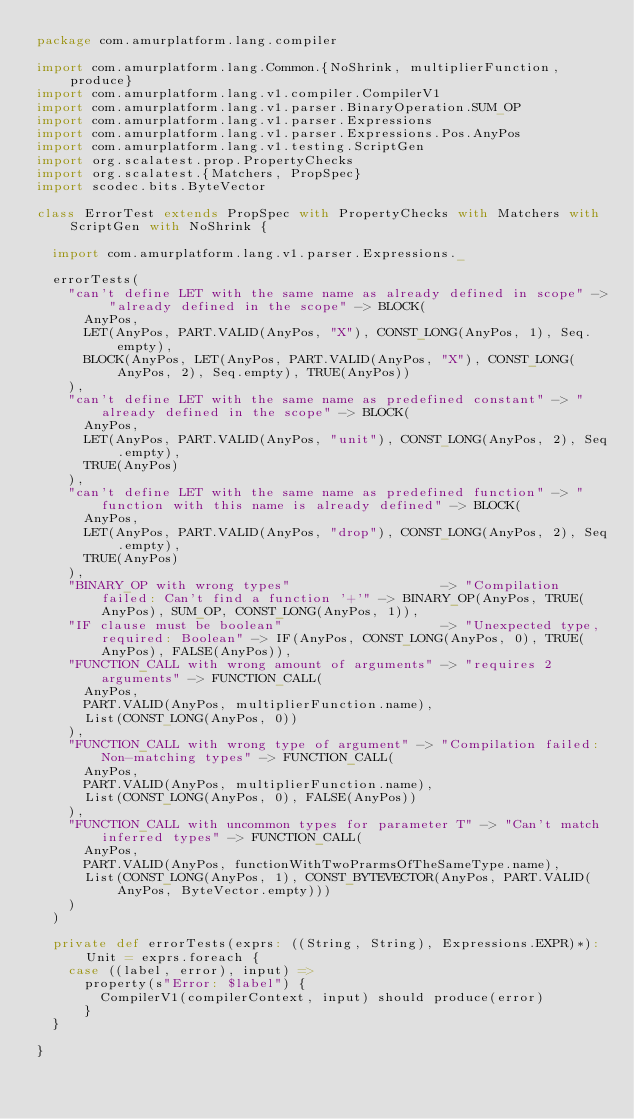Convert code to text. <code><loc_0><loc_0><loc_500><loc_500><_Scala_>package com.amurplatform.lang.compiler

import com.amurplatform.lang.Common.{NoShrink, multiplierFunction, produce}
import com.amurplatform.lang.v1.compiler.CompilerV1
import com.amurplatform.lang.v1.parser.BinaryOperation.SUM_OP
import com.amurplatform.lang.v1.parser.Expressions
import com.amurplatform.lang.v1.parser.Expressions.Pos.AnyPos
import com.amurplatform.lang.v1.testing.ScriptGen
import org.scalatest.prop.PropertyChecks
import org.scalatest.{Matchers, PropSpec}
import scodec.bits.ByteVector

class ErrorTest extends PropSpec with PropertyChecks with Matchers with ScriptGen with NoShrink {

  import com.amurplatform.lang.v1.parser.Expressions._

  errorTests(
    "can't define LET with the same name as already defined in scope" -> "already defined in the scope" -> BLOCK(
      AnyPos,
      LET(AnyPos, PART.VALID(AnyPos, "X"), CONST_LONG(AnyPos, 1), Seq.empty),
      BLOCK(AnyPos, LET(AnyPos, PART.VALID(AnyPos, "X"), CONST_LONG(AnyPos, 2), Seq.empty), TRUE(AnyPos))
    ),
    "can't define LET with the same name as predefined constant" -> "already defined in the scope" -> BLOCK(
      AnyPos,
      LET(AnyPos, PART.VALID(AnyPos, "unit"), CONST_LONG(AnyPos, 2), Seq.empty),
      TRUE(AnyPos)
    ),
    "can't define LET with the same name as predefined function" -> "function with this name is already defined" -> BLOCK(
      AnyPos,
      LET(AnyPos, PART.VALID(AnyPos, "drop"), CONST_LONG(AnyPos, 2), Seq.empty),
      TRUE(AnyPos)
    ),
    "BINARY_OP with wrong types"                   -> "Compilation failed: Can't find a function '+'" -> BINARY_OP(AnyPos, TRUE(AnyPos), SUM_OP, CONST_LONG(AnyPos, 1)),
    "IF clause must be boolean"                    -> "Unexpected type, required: Boolean" -> IF(AnyPos, CONST_LONG(AnyPos, 0), TRUE(AnyPos), FALSE(AnyPos)),
    "FUNCTION_CALL with wrong amount of arguments" -> "requires 2 arguments" -> FUNCTION_CALL(
      AnyPos,
      PART.VALID(AnyPos, multiplierFunction.name),
      List(CONST_LONG(AnyPos, 0))
    ),
    "FUNCTION_CALL with wrong type of argument" -> "Compilation failed: Non-matching types" -> FUNCTION_CALL(
      AnyPos,
      PART.VALID(AnyPos, multiplierFunction.name),
      List(CONST_LONG(AnyPos, 0), FALSE(AnyPos))
    ),
    "FUNCTION_CALL with uncommon types for parameter T" -> "Can't match inferred types" -> FUNCTION_CALL(
      AnyPos,
      PART.VALID(AnyPos, functionWithTwoPrarmsOfTheSameType.name),
      List(CONST_LONG(AnyPos, 1), CONST_BYTEVECTOR(AnyPos, PART.VALID(AnyPos, ByteVector.empty)))
    )
  )

  private def errorTests(exprs: ((String, String), Expressions.EXPR)*): Unit = exprs.foreach {
    case ((label, error), input) =>
      property(s"Error: $label") {
        CompilerV1(compilerContext, input) should produce(error)
      }
  }

}
</code> 